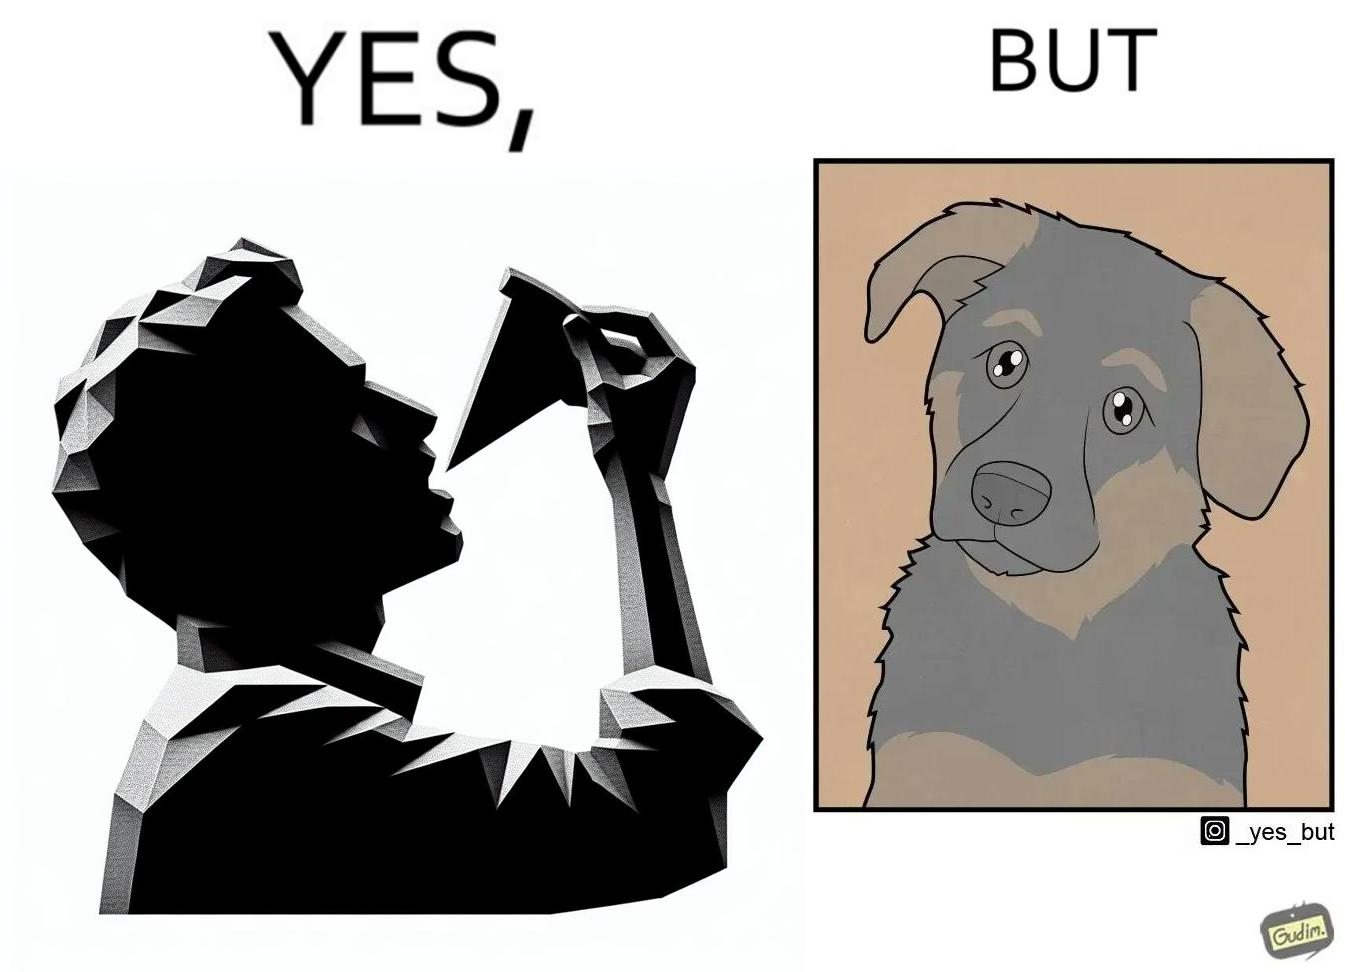Describe the contrast between the left and right parts of this image. In the left part of the image: It is a man eating a pizza In the right part of the image: It is a pet dog with teary eyes 